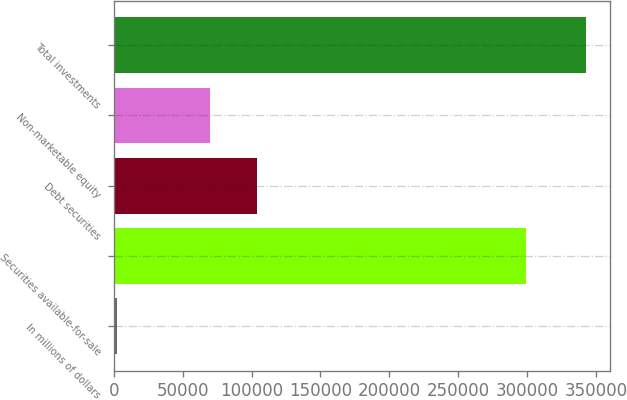<chart> <loc_0><loc_0><loc_500><loc_500><bar_chart><fcel>In millions of dollars<fcel>Securities available-for-sale<fcel>Debt securities<fcel>Non-marketable equity<fcel>Total investments<nl><fcel>2015<fcel>299136<fcel>104297<fcel>70203<fcel>342955<nl></chart> 